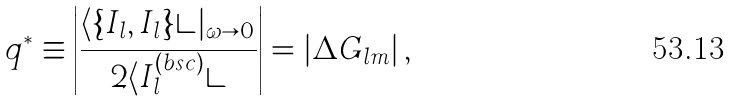<formula> <loc_0><loc_0><loc_500><loc_500>q ^ { * } \equiv \left | \frac { \langle \{ I _ { l } , I _ { l } \} \rangle | _ { \omega \to 0 } } { 2 \langle I ^ { ( b s c ) } _ { l } \rangle } \right | = | \Delta G _ { l m } | \, ,</formula> 